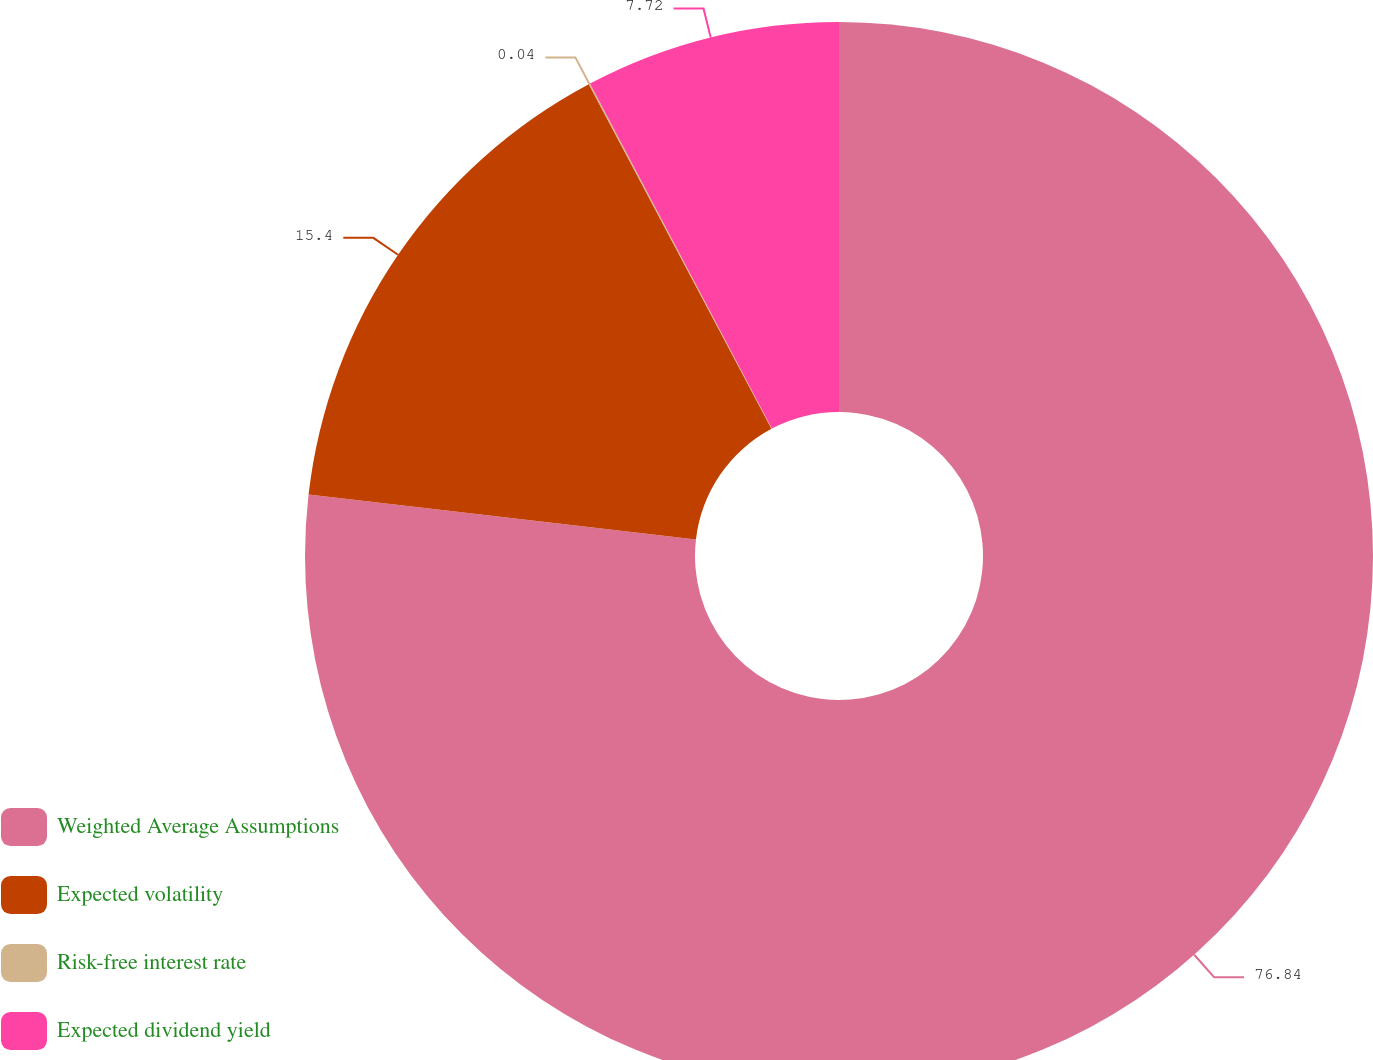Convert chart to OTSL. <chart><loc_0><loc_0><loc_500><loc_500><pie_chart><fcel>Weighted Average Assumptions<fcel>Expected volatility<fcel>Risk-free interest rate<fcel>Expected dividend yield<nl><fcel>76.83%<fcel>15.4%<fcel>0.04%<fcel>7.72%<nl></chart> 